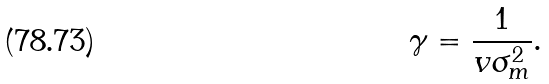Convert formula to latex. <formula><loc_0><loc_0><loc_500><loc_500>\gamma = \frac { 1 } { v \sigma _ { m } ^ { 2 } } .</formula> 